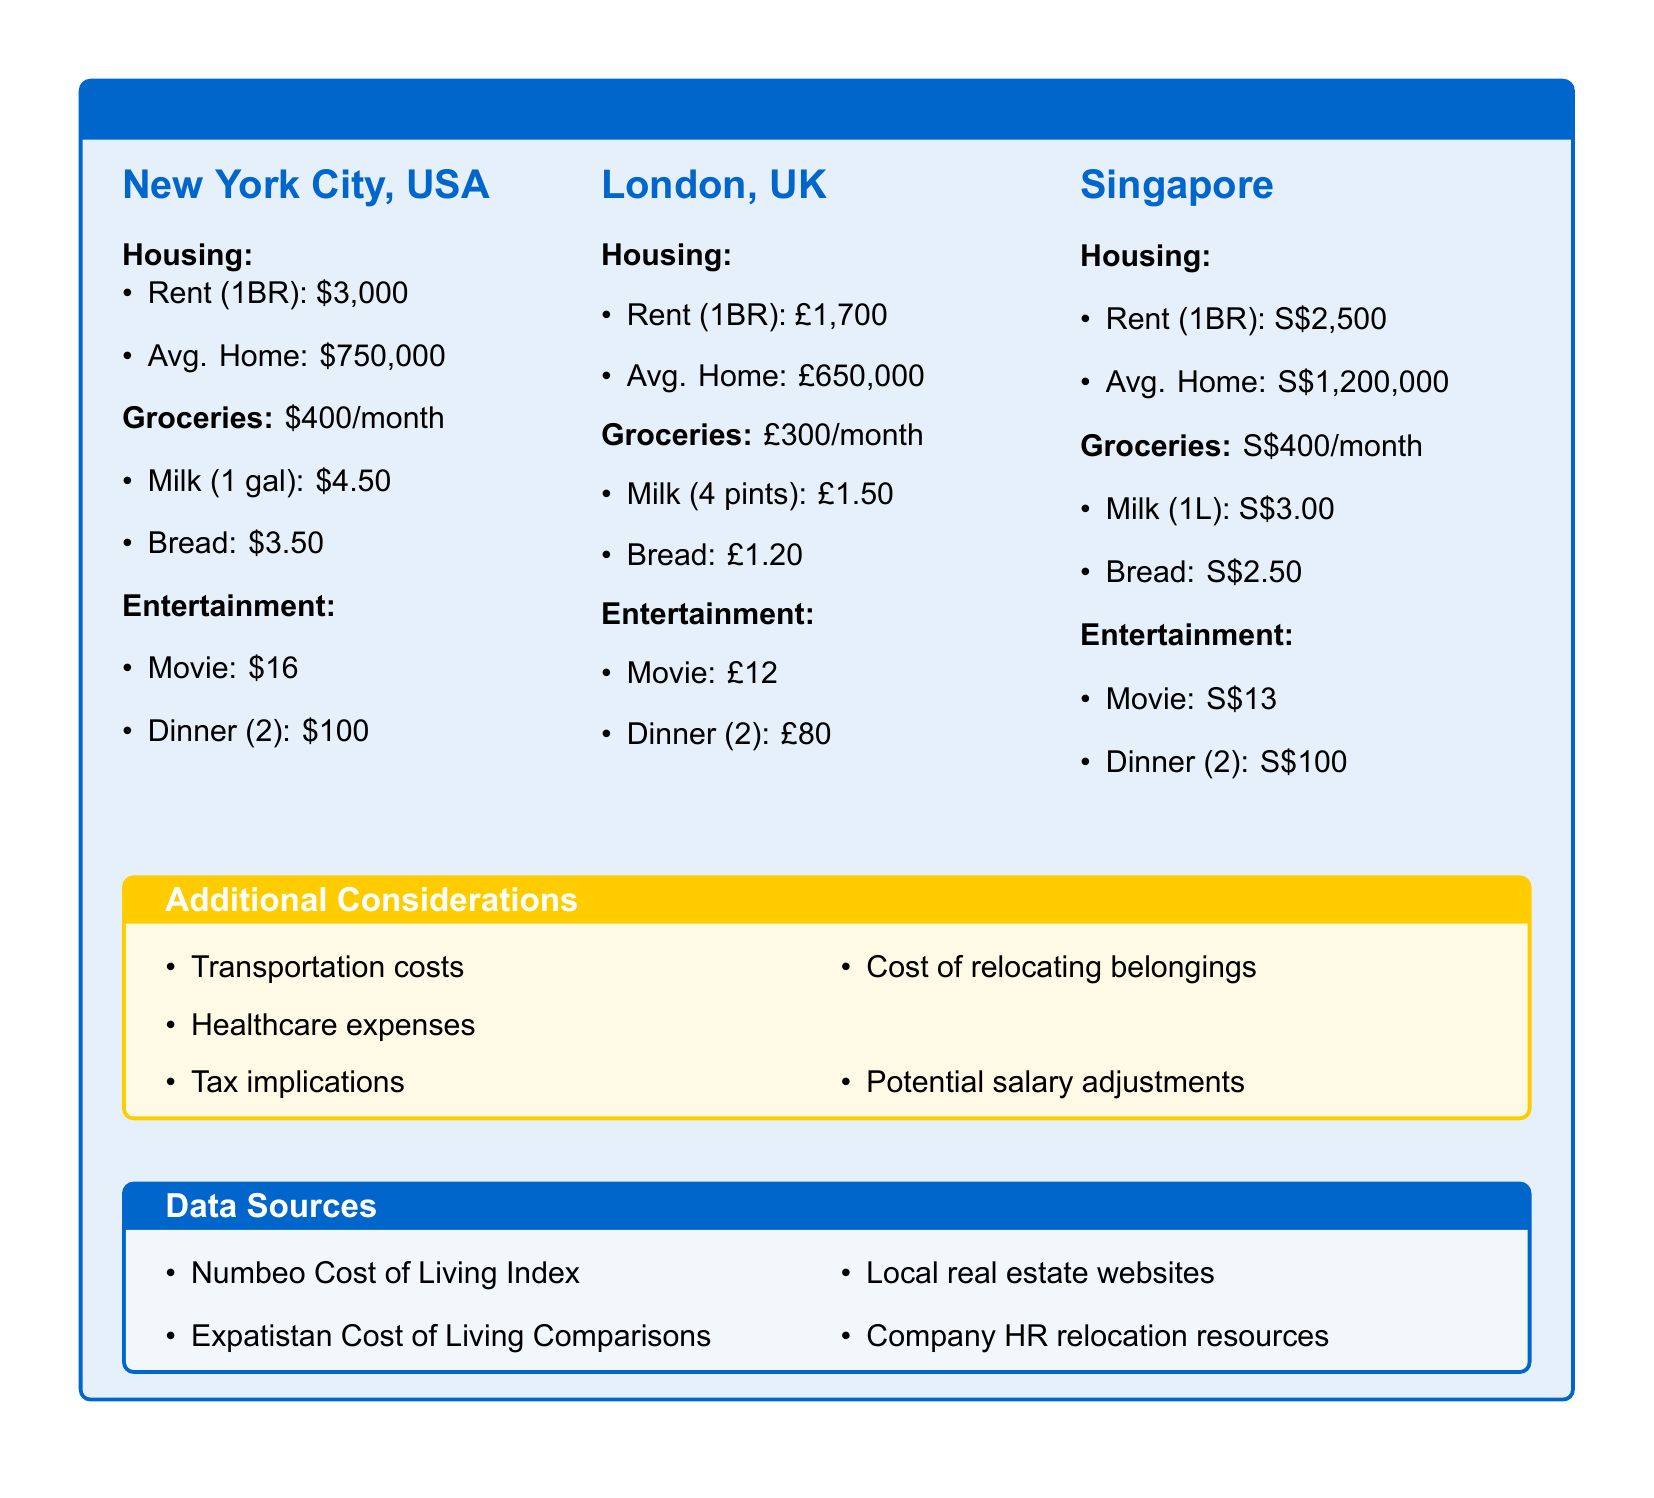what is the rent for a 1-bedroom apartment in New York City? The rent for a 1-bedroom apartment in New York City is listed as $3,000.
Answer: $3,000 what is the average home price in London? The average home price in London is £650,000.
Answer: £650,000 how much do groceries cost in Singapore per month? The document states that groceries in Singapore cost S$400 per month.
Answer: S$400 what is the cost of a dinner for two in New York City? A dinner for two in New York City costs $100.
Answer: $100 which city has the highest average home price? By comparing the average home prices, Singapore has the highest at S$1,200,000.
Answer: Singapore what is the cost of a movie ticket in London? The cost of a movie ticket in London is £12.
Answer: £12 list one additional consideration mentioned in the document. The document mentions transportation costs as one additional consideration.
Answer: Transportation costs what is the price of milk in New York City? The price of milk in New York City is $4.50 per gallon.
Answer: $4.50 how much is the rent for a 1-bedroom apartment in Singapore? The rent for a 1-bedroom apartment in Singapore is S$2,500.
Answer: S$2,500 